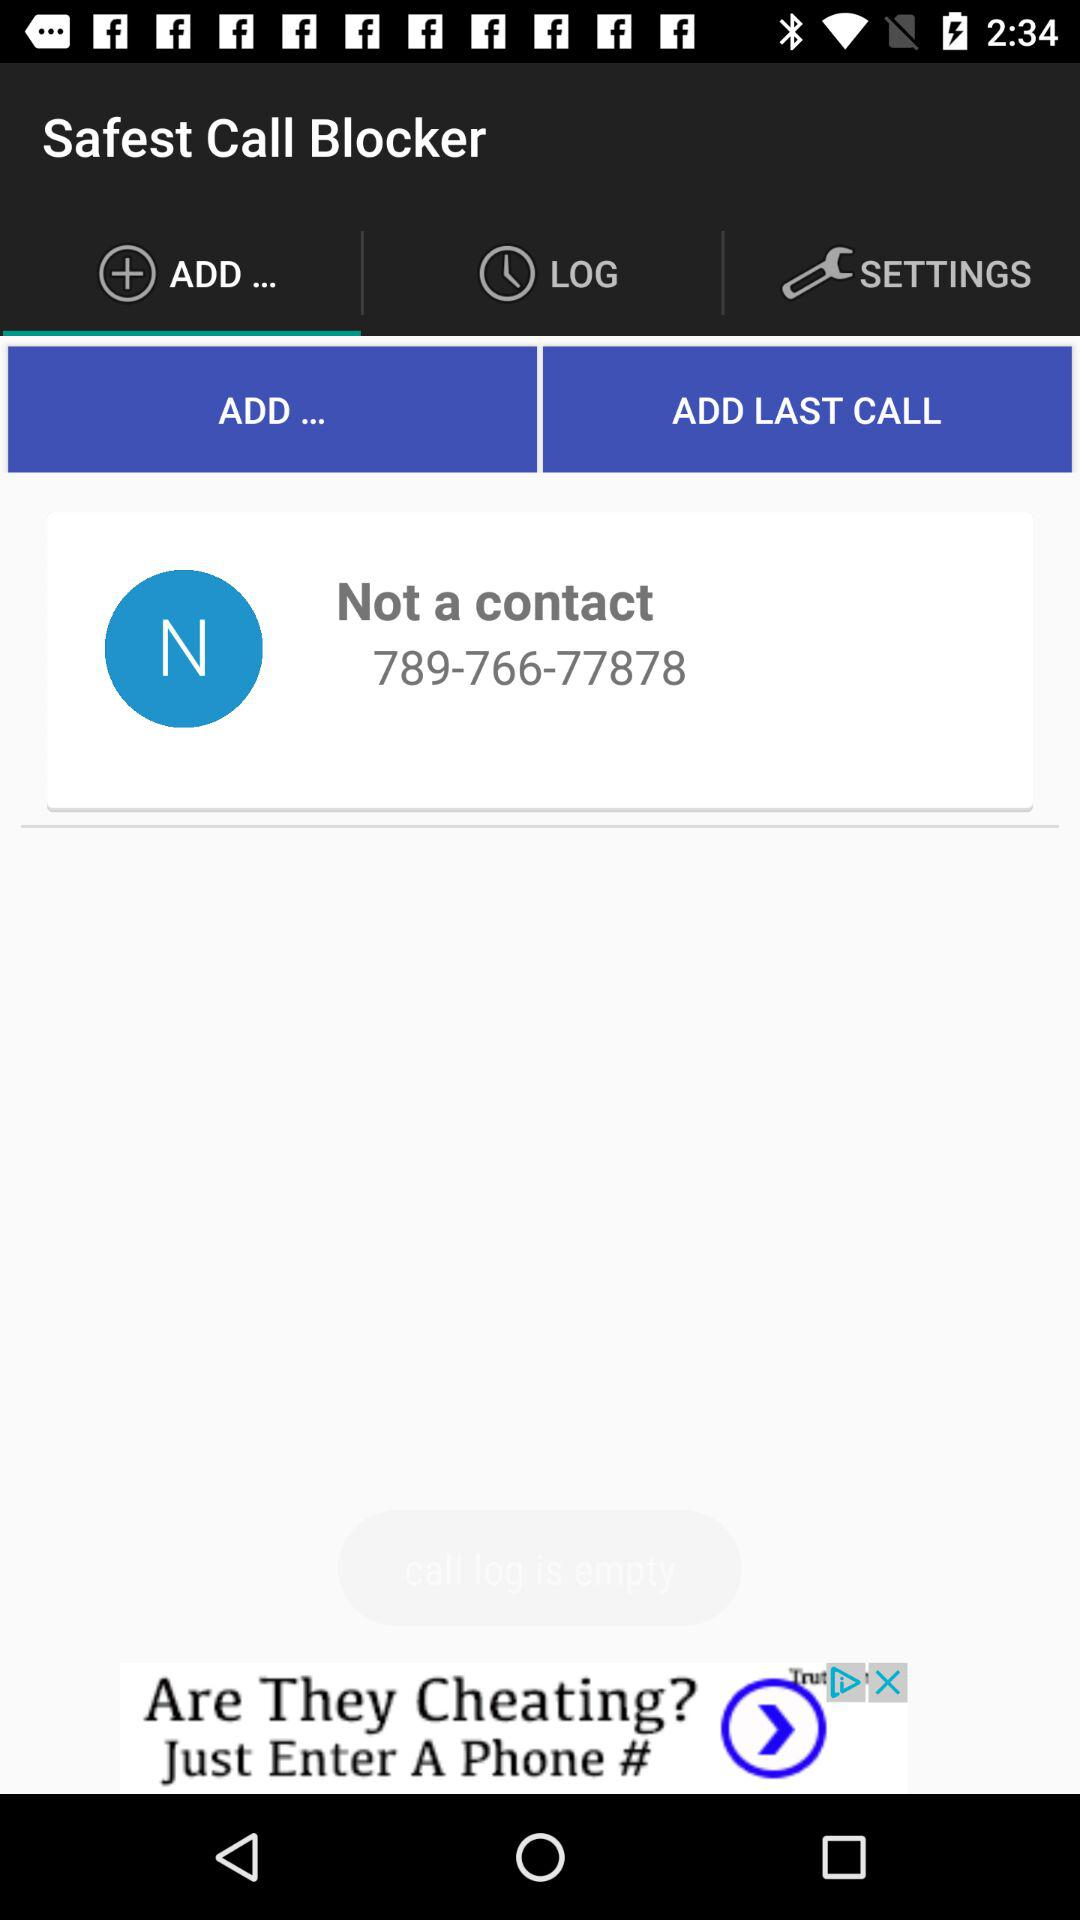What is the application name? The application name is "Safest Call Blocker". 